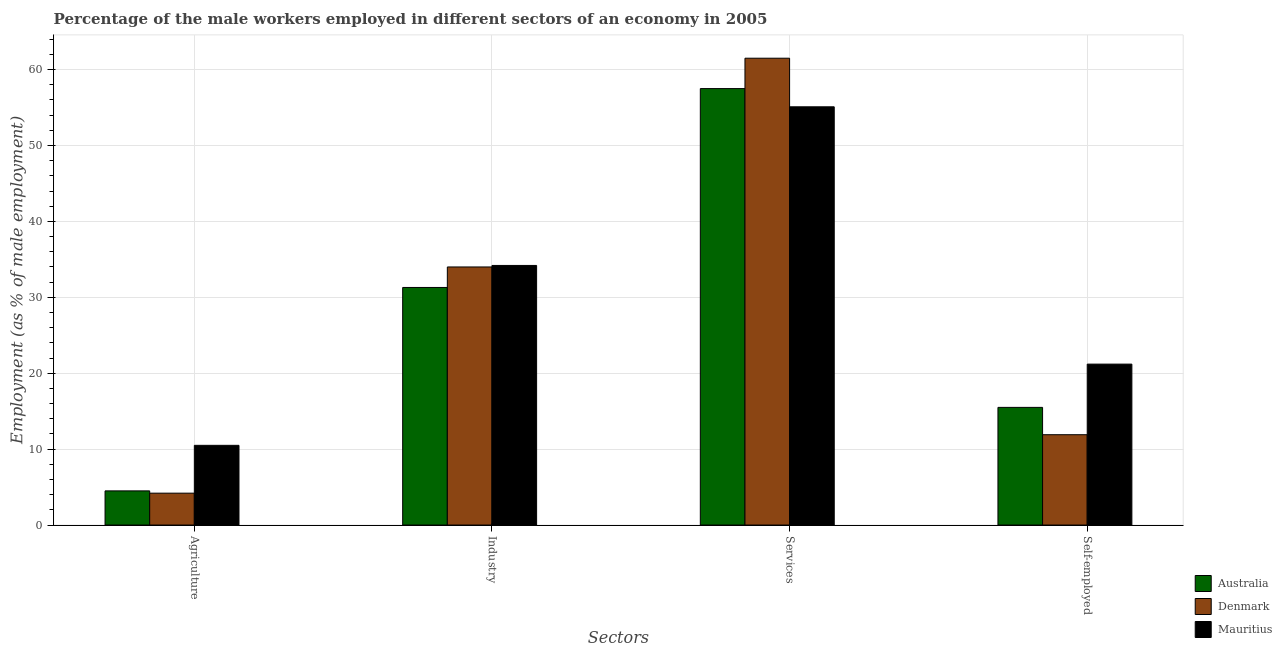How many different coloured bars are there?
Make the answer very short. 3. Are the number of bars per tick equal to the number of legend labels?
Your answer should be very brief. Yes. Are the number of bars on each tick of the X-axis equal?
Your answer should be very brief. Yes. How many bars are there on the 4th tick from the left?
Ensure brevity in your answer.  3. What is the label of the 1st group of bars from the left?
Provide a short and direct response. Agriculture. What is the percentage of male workers in industry in Mauritius?
Your response must be concise. 34.2. Across all countries, what is the minimum percentage of male workers in services?
Ensure brevity in your answer.  55.1. In which country was the percentage of male workers in agriculture maximum?
Your response must be concise. Mauritius. In which country was the percentage of male workers in industry minimum?
Keep it short and to the point. Australia. What is the total percentage of self employed male workers in the graph?
Keep it short and to the point. 48.6. What is the difference between the percentage of male workers in industry in Australia and that in Denmark?
Keep it short and to the point. -2.7. What is the difference between the percentage of male workers in services in Australia and the percentage of male workers in agriculture in Denmark?
Your answer should be very brief. 53.3. What is the average percentage of male workers in industry per country?
Your response must be concise. 33.17. What is the difference between the percentage of male workers in services and percentage of male workers in industry in Australia?
Your answer should be very brief. 26.2. What is the ratio of the percentage of self employed male workers in Mauritius to that in Denmark?
Your answer should be very brief. 1.78. Is the difference between the percentage of self employed male workers in Mauritius and Denmark greater than the difference between the percentage of male workers in agriculture in Mauritius and Denmark?
Make the answer very short. Yes. What is the difference between the highest and the lowest percentage of male workers in industry?
Provide a succinct answer. 2.9. Is the sum of the percentage of male workers in agriculture in Australia and Mauritius greater than the maximum percentage of self employed male workers across all countries?
Give a very brief answer. No. What does the 1st bar from the left in Industry represents?
Ensure brevity in your answer.  Australia. What does the 1st bar from the right in Self-employed represents?
Make the answer very short. Mauritius. Are all the bars in the graph horizontal?
Provide a succinct answer. No. How many countries are there in the graph?
Give a very brief answer. 3. What is the difference between two consecutive major ticks on the Y-axis?
Provide a succinct answer. 10. Are the values on the major ticks of Y-axis written in scientific E-notation?
Give a very brief answer. No. Does the graph contain grids?
Offer a terse response. Yes. Where does the legend appear in the graph?
Keep it short and to the point. Bottom right. How many legend labels are there?
Give a very brief answer. 3. How are the legend labels stacked?
Provide a succinct answer. Vertical. What is the title of the graph?
Make the answer very short. Percentage of the male workers employed in different sectors of an economy in 2005. Does "India" appear as one of the legend labels in the graph?
Keep it short and to the point. No. What is the label or title of the X-axis?
Offer a terse response. Sectors. What is the label or title of the Y-axis?
Your answer should be compact. Employment (as % of male employment). What is the Employment (as % of male employment) of Australia in Agriculture?
Your answer should be compact. 4.5. What is the Employment (as % of male employment) in Denmark in Agriculture?
Make the answer very short. 4.2. What is the Employment (as % of male employment) of Mauritius in Agriculture?
Your answer should be compact. 10.5. What is the Employment (as % of male employment) of Australia in Industry?
Ensure brevity in your answer.  31.3. What is the Employment (as % of male employment) in Denmark in Industry?
Provide a succinct answer. 34. What is the Employment (as % of male employment) in Mauritius in Industry?
Ensure brevity in your answer.  34.2. What is the Employment (as % of male employment) in Australia in Services?
Keep it short and to the point. 57.5. What is the Employment (as % of male employment) in Denmark in Services?
Keep it short and to the point. 61.5. What is the Employment (as % of male employment) of Mauritius in Services?
Make the answer very short. 55.1. What is the Employment (as % of male employment) of Australia in Self-employed?
Offer a terse response. 15.5. What is the Employment (as % of male employment) of Denmark in Self-employed?
Give a very brief answer. 11.9. What is the Employment (as % of male employment) in Mauritius in Self-employed?
Give a very brief answer. 21.2. Across all Sectors, what is the maximum Employment (as % of male employment) of Australia?
Keep it short and to the point. 57.5. Across all Sectors, what is the maximum Employment (as % of male employment) in Denmark?
Provide a short and direct response. 61.5. Across all Sectors, what is the maximum Employment (as % of male employment) of Mauritius?
Provide a short and direct response. 55.1. Across all Sectors, what is the minimum Employment (as % of male employment) in Denmark?
Offer a very short reply. 4.2. What is the total Employment (as % of male employment) in Australia in the graph?
Give a very brief answer. 108.8. What is the total Employment (as % of male employment) in Denmark in the graph?
Your answer should be very brief. 111.6. What is the total Employment (as % of male employment) of Mauritius in the graph?
Your answer should be very brief. 121. What is the difference between the Employment (as % of male employment) of Australia in Agriculture and that in Industry?
Give a very brief answer. -26.8. What is the difference between the Employment (as % of male employment) of Denmark in Agriculture and that in Industry?
Ensure brevity in your answer.  -29.8. What is the difference between the Employment (as % of male employment) in Mauritius in Agriculture and that in Industry?
Your answer should be very brief. -23.7. What is the difference between the Employment (as % of male employment) in Australia in Agriculture and that in Services?
Provide a short and direct response. -53. What is the difference between the Employment (as % of male employment) of Denmark in Agriculture and that in Services?
Give a very brief answer. -57.3. What is the difference between the Employment (as % of male employment) of Mauritius in Agriculture and that in Services?
Make the answer very short. -44.6. What is the difference between the Employment (as % of male employment) in Denmark in Agriculture and that in Self-employed?
Give a very brief answer. -7.7. What is the difference between the Employment (as % of male employment) in Australia in Industry and that in Services?
Provide a short and direct response. -26.2. What is the difference between the Employment (as % of male employment) in Denmark in Industry and that in Services?
Provide a short and direct response. -27.5. What is the difference between the Employment (as % of male employment) of Mauritius in Industry and that in Services?
Your response must be concise. -20.9. What is the difference between the Employment (as % of male employment) in Australia in Industry and that in Self-employed?
Offer a terse response. 15.8. What is the difference between the Employment (as % of male employment) in Denmark in Industry and that in Self-employed?
Provide a succinct answer. 22.1. What is the difference between the Employment (as % of male employment) of Mauritius in Industry and that in Self-employed?
Offer a very short reply. 13. What is the difference between the Employment (as % of male employment) of Australia in Services and that in Self-employed?
Give a very brief answer. 42. What is the difference between the Employment (as % of male employment) of Denmark in Services and that in Self-employed?
Keep it short and to the point. 49.6. What is the difference between the Employment (as % of male employment) of Mauritius in Services and that in Self-employed?
Ensure brevity in your answer.  33.9. What is the difference between the Employment (as % of male employment) in Australia in Agriculture and the Employment (as % of male employment) in Denmark in Industry?
Make the answer very short. -29.5. What is the difference between the Employment (as % of male employment) in Australia in Agriculture and the Employment (as % of male employment) in Mauritius in Industry?
Your response must be concise. -29.7. What is the difference between the Employment (as % of male employment) of Denmark in Agriculture and the Employment (as % of male employment) of Mauritius in Industry?
Your response must be concise. -30. What is the difference between the Employment (as % of male employment) in Australia in Agriculture and the Employment (as % of male employment) in Denmark in Services?
Ensure brevity in your answer.  -57. What is the difference between the Employment (as % of male employment) of Australia in Agriculture and the Employment (as % of male employment) of Mauritius in Services?
Make the answer very short. -50.6. What is the difference between the Employment (as % of male employment) of Denmark in Agriculture and the Employment (as % of male employment) of Mauritius in Services?
Offer a very short reply. -50.9. What is the difference between the Employment (as % of male employment) in Australia in Agriculture and the Employment (as % of male employment) in Denmark in Self-employed?
Make the answer very short. -7.4. What is the difference between the Employment (as % of male employment) of Australia in Agriculture and the Employment (as % of male employment) of Mauritius in Self-employed?
Your answer should be compact. -16.7. What is the difference between the Employment (as % of male employment) of Australia in Industry and the Employment (as % of male employment) of Denmark in Services?
Offer a terse response. -30.2. What is the difference between the Employment (as % of male employment) in Australia in Industry and the Employment (as % of male employment) in Mauritius in Services?
Provide a short and direct response. -23.8. What is the difference between the Employment (as % of male employment) in Denmark in Industry and the Employment (as % of male employment) in Mauritius in Services?
Provide a short and direct response. -21.1. What is the difference between the Employment (as % of male employment) in Australia in Industry and the Employment (as % of male employment) in Denmark in Self-employed?
Offer a very short reply. 19.4. What is the difference between the Employment (as % of male employment) of Australia in Industry and the Employment (as % of male employment) of Mauritius in Self-employed?
Offer a very short reply. 10.1. What is the difference between the Employment (as % of male employment) of Denmark in Industry and the Employment (as % of male employment) of Mauritius in Self-employed?
Your answer should be very brief. 12.8. What is the difference between the Employment (as % of male employment) of Australia in Services and the Employment (as % of male employment) of Denmark in Self-employed?
Provide a short and direct response. 45.6. What is the difference between the Employment (as % of male employment) in Australia in Services and the Employment (as % of male employment) in Mauritius in Self-employed?
Provide a short and direct response. 36.3. What is the difference between the Employment (as % of male employment) of Denmark in Services and the Employment (as % of male employment) of Mauritius in Self-employed?
Give a very brief answer. 40.3. What is the average Employment (as % of male employment) in Australia per Sectors?
Your answer should be very brief. 27.2. What is the average Employment (as % of male employment) in Denmark per Sectors?
Give a very brief answer. 27.9. What is the average Employment (as % of male employment) of Mauritius per Sectors?
Provide a short and direct response. 30.25. What is the difference between the Employment (as % of male employment) of Australia and Employment (as % of male employment) of Denmark in Agriculture?
Offer a very short reply. 0.3. What is the difference between the Employment (as % of male employment) in Australia and Employment (as % of male employment) in Mauritius in Agriculture?
Your response must be concise. -6. What is the difference between the Employment (as % of male employment) of Australia and Employment (as % of male employment) of Denmark in Industry?
Your response must be concise. -2.7. What is the difference between the Employment (as % of male employment) in Australia and Employment (as % of male employment) in Mauritius in Industry?
Give a very brief answer. -2.9. What is the difference between the Employment (as % of male employment) of Denmark and Employment (as % of male employment) of Mauritius in Industry?
Provide a short and direct response. -0.2. What is the difference between the Employment (as % of male employment) in Australia and Employment (as % of male employment) in Mauritius in Services?
Provide a short and direct response. 2.4. What is the difference between the Employment (as % of male employment) in Denmark and Employment (as % of male employment) in Mauritius in Services?
Provide a short and direct response. 6.4. What is the difference between the Employment (as % of male employment) of Australia and Employment (as % of male employment) of Denmark in Self-employed?
Your response must be concise. 3.6. What is the difference between the Employment (as % of male employment) in Australia and Employment (as % of male employment) in Mauritius in Self-employed?
Your answer should be compact. -5.7. What is the ratio of the Employment (as % of male employment) in Australia in Agriculture to that in Industry?
Your answer should be compact. 0.14. What is the ratio of the Employment (as % of male employment) in Denmark in Agriculture to that in Industry?
Ensure brevity in your answer.  0.12. What is the ratio of the Employment (as % of male employment) of Mauritius in Agriculture to that in Industry?
Offer a terse response. 0.31. What is the ratio of the Employment (as % of male employment) of Australia in Agriculture to that in Services?
Make the answer very short. 0.08. What is the ratio of the Employment (as % of male employment) of Denmark in Agriculture to that in Services?
Provide a succinct answer. 0.07. What is the ratio of the Employment (as % of male employment) of Mauritius in Agriculture to that in Services?
Offer a terse response. 0.19. What is the ratio of the Employment (as % of male employment) of Australia in Agriculture to that in Self-employed?
Your answer should be compact. 0.29. What is the ratio of the Employment (as % of male employment) in Denmark in Agriculture to that in Self-employed?
Offer a very short reply. 0.35. What is the ratio of the Employment (as % of male employment) in Mauritius in Agriculture to that in Self-employed?
Provide a short and direct response. 0.5. What is the ratio of the Employment (as % of male employment) of Australia in Industry to that in Services?
Give a very brief answer. 0.54. What is the ratio of the Employment (as % of male employment) in Denmark in Industry to that in Services?
Ensure brevity in your answer.  0.55. What is the ratio of the Employment (as % of male employment) of Mauritius in Industry to that in Services?
Keep it short and to the point. 0.62. What is the ratio of the Employment (as % of male employment) of Australia in Industry to that in Self-employed?
Your answer should be compact. 2.02. What is the ratio of the Employment (as % of male employment) of Denmark in Industry to that in Self-employed?
Make the answer very short. 2.86. What is the ratio of the Employment (as % of male employment) in Mauritius in Industry to that in Self-employed?
Your answer should be compact. 1.61. What is the ratio of the Employment (as % of male employment) in Australia in Services to that in Self-employed?
Offer a very short reply. 3.71. What is the ratio of the Employment (as % of male employment) in Denmark in Services to that in Self-employed?
Your answer should be very brief. 5.17. What is the ratio of the Employment (as % of male employment) of Mauritius in Services to that in Self-employed?
Provide a succinct answer. 2.6. What is the difference between the highest and the second highest Employment (as % of male employment) in Australia?
Provide a short and direct response. 26.2. What is the difference between the highest and the second highest Employment (as % of male employment) in Mauritius?
Offer a very short reply. 20.9. What is the difference between the highest and the lowest Employment (as % of male employment) in Denmark?
Your answer should be compact. 57.3. What is the difference between the highest and the lowest Employment (as % of male employment) of Mauritius?
Your answer should be compact. 44.6. 